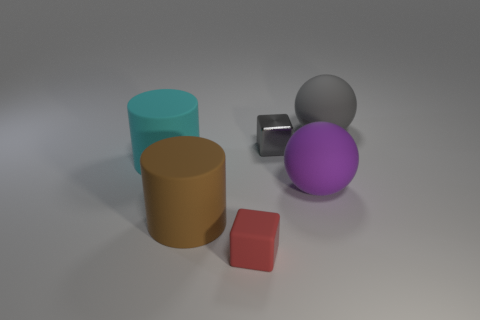Add 1 tiny cubes. How many objects exist? 7 Subtract all cylinders. How many objects are left? 4 Subtract 0 yellow cylinders. How many objects are left? 6 Subtract all tiny purple matte balls. Subtract all cyan rubber cylinders. How many objects are left? 5 Add 5 large purple spheres. How many large purple spheres are left? 6 Add 1 big green things. How many big green things exist? 1 